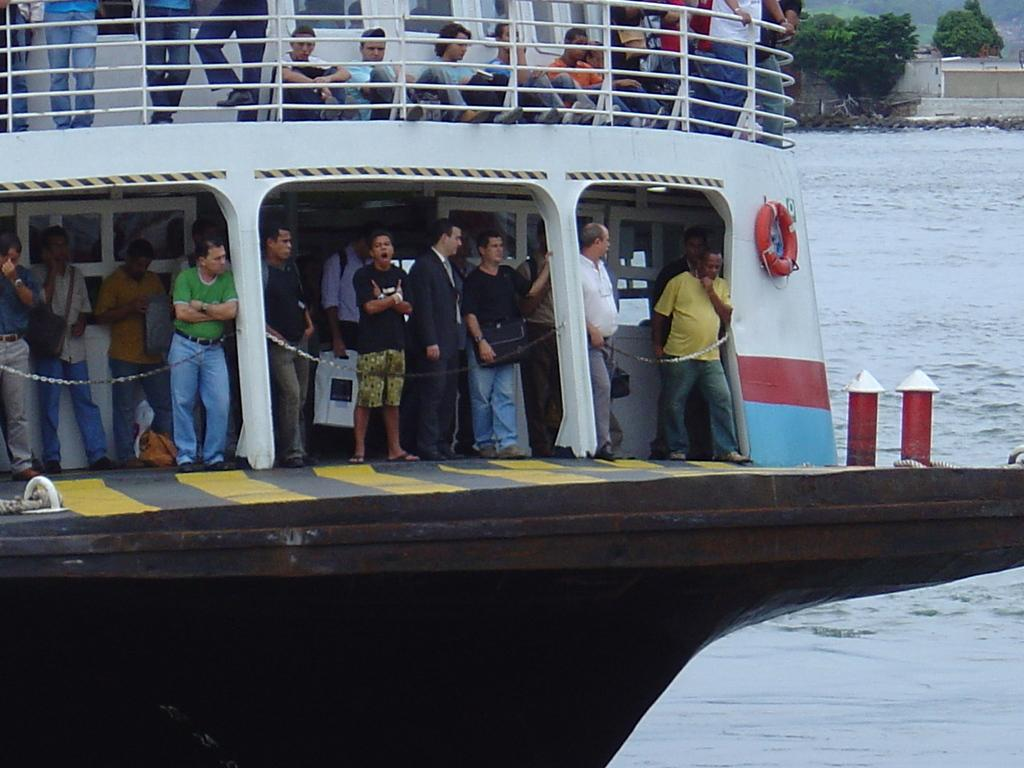What is the main subject of the image? The main subject of the image is a ship. Can you describe the people in the image? There is a group of people in the image. What type of natural environment is visible in the image? There are trees in the image. What type of man-made structures can be seen in the image? There are buildings in the image. What is the ship situated on or near in the image? There is water visible in the image, which suggests that the ship is on or near water. What type of insurance policy do the trees in the image have? There is no information about insurance policies for the trees in the image, as they are not living beings that can have insurance. 